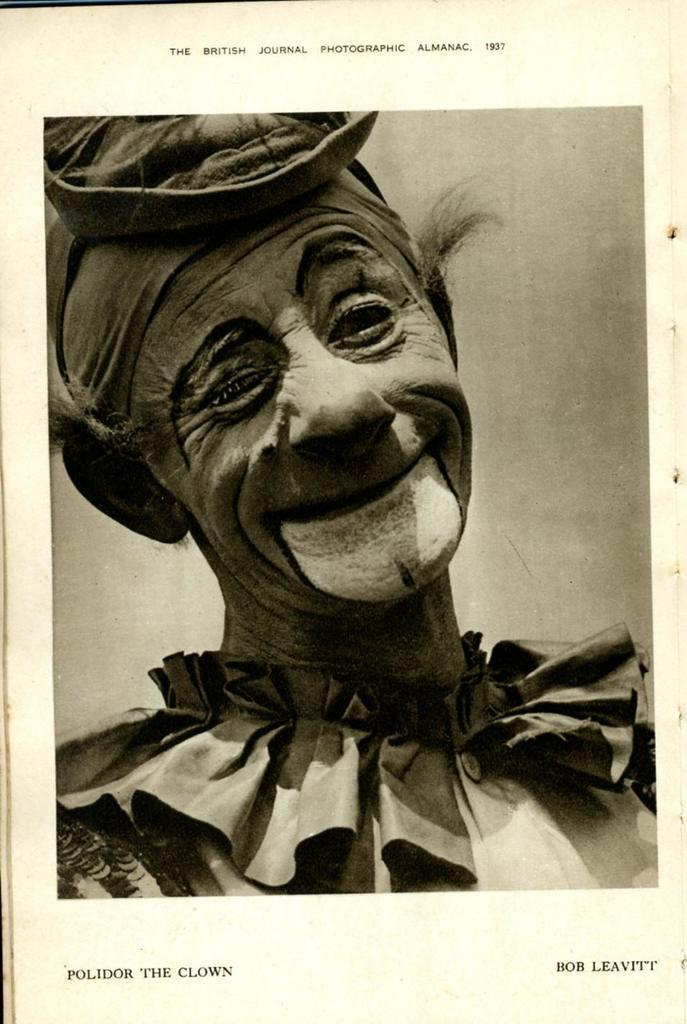How would you summarize this image in a sentence or two? In this image, we can see photo of a picture contains a person and some text. 